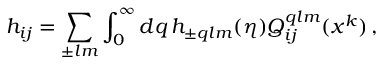Convert formula to latex. <formula><loc_0><loc_0><loc_500><loc_500>h _ { i j } = \sum _ { \pm l m } \int _ { 0 } ^ { \infty } d q \, h _ { \pm q l m } ( \eta ) Q _ { i j } ^ { q l m } ( x ^ { k } ) \, ,</formula> 